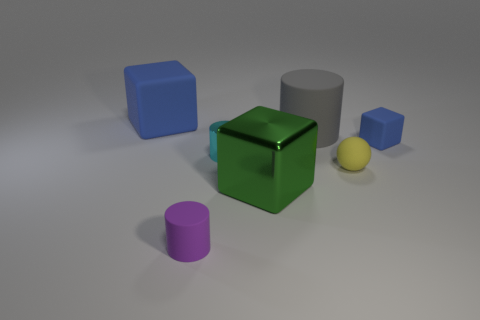What color is the large object in front of the rubber cube that is on the right side of the blue cube to the left of the small purple cylinder?
Ensure brevity in your answer.  Green. How many other things are there of the same size as the yellow object?
Your answer should be compact. 3. Are there any other things that are the same shape as the big gray matte thing?
Offer a terse response. Yes. What is the color of the other small metal thing that is the same shape as the purple thing?
Ensure brevity in your answer.  Cyan. There is a small block that is made of the same material as the large blue cube; what color is it?
Ensure brevity in your answer.  Blue. Are there the same number of blue matte cubes to the right of the small purple cylinder and yellow spheres?
Your answer should be compact. Yes. There is a blue cube to the left of the purple object; is its size the same as the small ball?
Provide a short and direct response. No. There is another block that is the same size as the metal block; what is its color?
Make the answer very short. Blue. There is a blue matte block that is right of the big object in front of the gray thing; are there any matte things in front of it?
Your answer should be very brief. Yes. There is a cube right of the yellow thing; what is its material?
Ensure brevity in your answer.  Rubber. 